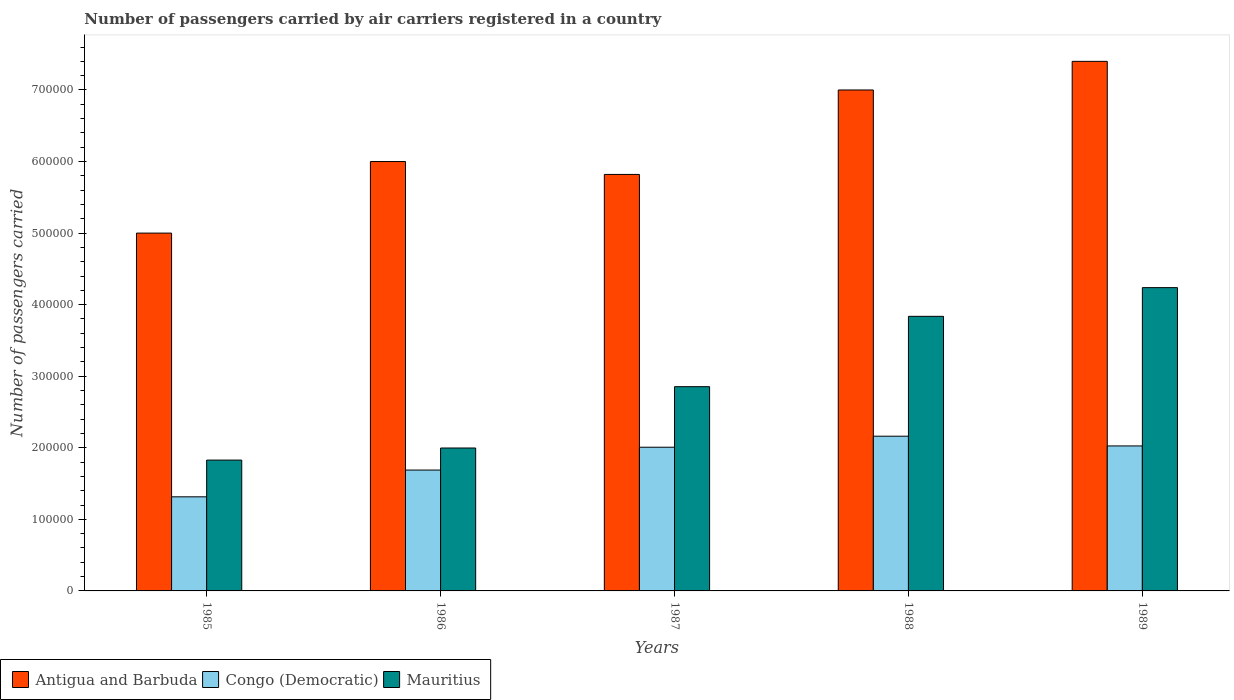How many groups of bars are there?
Keep it short and to the point. 5. How many bars are there on the 3rd tick from the left?
Your answer should be very brief. 3. What is the number of passengers carried by air carriers in Congo (Democratic) in 1987?
Offer a very short reply. 2.01e+05. Across all years, what is the maximum number of passengers carried by air carriers in Congo (Democratic)?
Offer a very short reply. 2.16e+05. Across all years, what is the minimum number of passengers carried by air carriers in Congo (Democratic)?
Ensure brevity in your answer.  1.32e+05. In which year was the number of passengers carried by air carriers in Congo (Democratic) maximum?
Offer a terse response. 1988. What is the total number of passengers carried by air carriers in Antigua and Barbuda in the graph?
Give a very brief answer. 3.12e+06. What is the difference between the number of passengers carried by air carriers in Congo (Democratic) in 1987 and that in 1988?
Your response must be concise. -1.54e+04. What is the difference between the number of passengers carried by air carriers in Antigua and Barbuda in 1986 and the number of passengers carried by air carriers in Congo (Democratic) in 1985?
Keep it short and to the point. 4.68e+05. What is the average number of passengers carried by air carriers in Antigua and Barbuda per year?
Give a very brief answer. 6.24e+05. In the year 1985, what is the difference between the number of passengers carried by air carriers in Antigua and Barbuda and number of passengers carried by air carriers in Mauritius?
Your response must be concise. 3.17e+05. What is the ratio of the number of passengers carried by air carriers in Congo (Democratic) in 1985 to that in 1986?
Offer a very short reply. 0.78. Is the number of passengers carried by air carriers in Mauritius in 1986 less than that in 1988?
Your answer should be very brief. Yes. Is the difference between the number of passengers carried by air carriers in Antigua and Barbuda in 1985 and 1988 greater than the difference between the number of passengers carried by air carriers in Mauritius in 1985 and 1988?
Provide a succinct answer. Yes. What is the difference between the highest and the lowest number of passengers carried by air carriers in Congo (Democratic)?
Give a very brief answer. 8.47e+04. In how many years, is the number of passengers carried by air carriers in Congo (Democratic) greater than the average number of passengers carried by air carriers in Congo (Democratic) taken over all years?
Offer a terse response. 3. Is the sum of the number of passengers carried by air carriers in Antigua and Barbuda in 1985 and 1989 greater than the maximum number of passengers carried by air carriers in Congo (Democratic) across all years?
Make the answer very short. Yes. What does the 1st bar from the left in 1987 represents?
Offer a very short reply. Antigua and Barbuda. What does the 1st bar from the right in 1985 represents?
Offer a terse response. Mauritius. Is it the case that in every year, the sum of the number of passengers carried by air carriers in Antigua and Barbuda and number of passengers carried by air carriers in Mauritius is greater than the number of passengers carried by air carriers in Congo (Democratic)?
Your answer should be very brief. Yes. Are all the bars in the graph horizontal?
Your response must be concise. No. How many years are there in the graph?
Offer a terse response. 5. Does the graph contain any zero values?
Your answer should be very brief. No. How are the legend labels stacked?
Ensure brevity in your answer.  Horizontal. What is the title of the graph?
Your answer should be very brief. Number of passengers carried by air carriers registered in a country. What is the label or title of the X-axis?
Offer a very short reply. Years. What is the label or title of the Y-axis?
Offer a very short reply. Number of passengers carried. What is the Number of passengers carried of Congo (Democratic) in 1985?
Offer a terse response. 1.32e+05. What is the Number of passengers carried in Mauritius in 1985?
Your answer should be very brief. 1.83e+05. What is the Number of passengers carried in Antigua and Barbuda in 1986?
Your response must be concise. 6.00e+05. What is the Number of passengers carried in Congo (Democratic) in 1986?
Your response must be concise. 1.69e+05. What is the Number of passengers carried of Mauritius in 1986?
Your answer should be very brief. 2.00e+05. What is the Number of passengers carried in Antigua and Barbuda in 1987?
Make the answer very short. 5.82e+05. What is the Number of passengers carried of Congo (Democratic) in 1987?
Provide a succinct answer. 2.01e+05. What is the Number of passengers carried of Mauritius in 1987?
Make the answer very short. 2.85e+05. What is the Number of passengers carried in Antigua and Barbuda in 1988?
Offer a very short reply. 7.00e+05. What is the Number of passengers carried in Congo (Democratic) in 1988?
Your answer should be compact. 2.16e+05. What is the Number of passengers carried in Mauritius in 1988?
Make the answer very short. 3.84e+05. What is the Number of passengers carried of Antigua and Barbuda in 1989?
Make the answer very short. 7.40e+05. What is the Number of passengers carried of Congo (Democratic) in 1989?
Provide a succinct answer. 2.03e+05. What is the Number of passengers carried in Mauritius in 1989?
Your answer should be compact. 4.24e+05. Across all years, what is the maximum Number of passengers carried of Antigua and Barbuda?
Give a very brief answer. 7.40e+05. Across all years, what is the maximum Number of passengers carried in Congo (Democratic)?
Your response must be concise. 2.16e+05. Across all years, what is the maximum Number of passengers carried of Mauritius?
Give a very brief answer. 4.24e+05. Across all years, what is the minimum Number of passengers carried of Antigua and Barbuda?
Offer a very short reply. 5.00e+05. Across all years, what is the minimum Number of passengers carried of Congo (Democratic)?
Provide a succinct answer. 1.32e+05. Across all years, what is the minimum Number of passengers carried of Mauritius?
Provide a succinct answer. 1.83e+05. What is the total Number of passengers carried of Antigua and Barbuda in the graph?
Provide a succinct answer. 3.12e+06. What is the total Number of passengers carried in Congo (Democratic) in the graph?
Provide a succinct answer. 9.20e+05. What is the total Number of passengers carried in Mauritius in the graph?
Provide a succinct answer. 1.48e+06. What is the difference between the Number of passengers carried in Antigua and Barbuda in 1985 and that in 1986?
Your answer should be compact. -1.00e+05. What is the difference between the Number of passengers carried in Congo (Democratic) in 1985 and that in 1986?
Give a very brief answer. -3.74e+04. What is the difference between the Number of passengers carried of Mauritius in 1985 and that in 1986?
Your answer should be compact. -1.69e+04. What is the difference between the Number of passengers carried of Antigua and Barbuda in 1985 and that in 1987?
Ensure brevity in your answer.  -8.20e+04. What is the difference between the Number of passengers carried of Congo (Democratic) in 1985 and that in 1987?
Your response must be concise. -6.93e+04. What is the difference between the Number of passengers carried in Mauritius in 1985 and that in 1987?
Make the answer very short. -1.03e+05. What is the difference between the Number of passengers carried in Congo (Democratic) in 1985 and that in 1988?
Offer a very short reply. -8.47e+04. What is the difference between the Number of passengers carried of Mauritius in 1985 and that in 1988?
Your response must be concise. -2.01e+05. What is the difference between the Number of passengers carried in Antigua and Barbuda in 1985 and that in 1989?
Offer a very short reply. -2.40e+05. What is the difference between the Number of passengers carried of Congo (Democratic) in 1985 and that in 1989?
Provide a short and direct response. -7.11e+04. What is the difference between the Number of passengers carried of Mauritius in 1985 and that in 1989?
Provide a short and direct response. -2.41e+05. What is the difference between the Number of passengers carried of Antigua and Barbuda in 1986 and that in 1987?
Offer a very short reply. 1.80e+04. What is the difference between the Number of passengers carried of Congo (Democratic) in 1986 and that in 1987?
Your response must be concise. -3.19e+04. What is the difference between the Number of passengers carried of Mauritius in 1986 and that in 1987?
Keep it short and to the point. -8.57e+04. What is the difference between the Number of passengers carried of Congo (Democratic) in 1986 and that in 1988?
Provide a succinct answer. -4.73e+04. What is the difference between the Number of passengers carried in Mauritius in 1986 and that in 1988?
Your response must be concise. -1.84e+05. What is the difference between the Number of passengers carried in Congo (Democratic) in 1986 and that in 1989?
Make the answer very short. -3.37e+04. What is the difference between the Number of passengers carried of Mauritius in 1986 and that in 1989?
Make the answer very short. -2.24e+05. What is the difference between the Number of passengers carried of Antigua and Barbuda in 1987 and that in 1988?
Ensure brevity in your answer.  -1.18e+05. What is the difference between the Number of passengers carried in Congo (Democratic) in 1987 and that in 1988?
Your answer should be very brief. -1.54e+04. What is the difference between the Number of passengers carried of Mauritius in 1987 and that in 1988?
Offer a terse response. -9.83e+04. What is the difference between the Number of passengers carried of Antigua and Barbuda in 1987 and that in 1989?
Offer a very short reply. -1.58e+05. What is the difference between the Number of passengers carried in Congo (Democratic) in 1987 and that in 1989?
Keep it short and to the point. -1800. What is the difference between the Number of passengers carried in Mauritius in 1987 and that in 1989?
Ensure brevity in your answer.  -1.38e+05. What is the difference between the Number of passengers carried in Congo (Democratic) in 1988 and that in 1989?
Your answer should be very brief. 1.36e+04. What is the difference between the Number of passengers carried of Mauritius in 1988 and that in 1989?
Offer a very short reply. -4.01e+04. What is the difference between the Number of passengers carried in Antigua and Barbuda in 1985 and the Number of passengers carried in Congo (Democratic) in 1986?
Your answer should be very brief. 3.31e+05. What is the difference between the Number of passengers carried in Antigua and Barbuda in 1985 and the Number of passengers carried in Mauritius in 1986?
Keep it short and to the point. 3.00e+05. What is the difference between the Number of passengers carried of Congo (Democratic) in 1985 and the Number of passengers carried of Mauritius in 1986?
Offer a very short reply. -6.82e+04. What is the difference between the Number of passengers carried in Antigua and Barbuda in 1985 and the Number of passengers carried in Congo (Democratic) in 1987?
Your answer should be very brief. 2.99e+05. What is the difference between the Number of passengers carried in Antigua and Barbuda in 1985 and the Number of passengers carried in Mauritius in 1987?
Offer a very short reply. 2.15e+05. What is the difference between the Number of passengers carried in Congo (Democratic) in 1985 and the Number of passengers carried in Mauritius in 1987?
Ensure brevity in your answer.  -1.54e+05. What is the difference between the Number of passengers carried of Antigua and Barbuda in 1985 and the Number of passengers carried of Congo (Democratic) in 1988?
Provide a succinct answer. 2.84e+05. What is the difference between the Number of passengers carried of Antigua and Barbuda in 1985 and the Number of passengers carried of Mauritius in 1988?
Keep it short and to the point. 1.16e+05. What is the difference between the Number of passengers carried in Congo (Democratic) in 1985 and the Number of passengers carried in Mauritius in 1988?
Provide a succinct answer. -2.52e+05. What is the difference between the Number of passengers carried of Antigua and Barbuda in 1985 and the Number of passengers carried of Congo (Democratic) in 1989?
Make the answer very short. 2.97e+05. What is the difference between the Number of passengers carried of Antigua and Barbuda in 1985 and the Number of passengers carried of Mauritius in 1989?
Your response must be concise. 7.62e+04. What is the difference between the Number of passengers carried of Congo (Democratic) in 1985 and the Number of passengers carried of Mauritius in 1989?
Give a very brief answer. -2.92e+05. What is the difference between the Number of passengers carried of Antigua and Barbuda in 1986 and the Number of passengers carried of Congo (Democratic) in 1987?
Ensure brevity in your answer.  3.99e+05. What is the difference between the Number of passengers carried in Antigua and Barbuda in 1986 and the Number of passengers carried in Mauritius in 1987?
Your answer should be very brief. 3.15e+05. What is the difference between the Number of passengers carried in Congo (Democratic) in 1986 and the Number of passengers carried in Mauritius in 1987?
Make the answer very short. -1.16e+05. What is the difference between the Number of passengers carried of Antigua and Barbuda in 1986 and the Number of passengers carried of Congo (Democratic) in 1988?
Your answer should be very brief. 3.84e+05. What is the difference between the Number of passengers carried of Antigua and Barbuda in 1986 and the Number of passengers carried of Mauritius in 1988?
Your answer should be very brief. 2.16e+05. What is the difference between the Number of passengers carried of Congo (Democratic) in 1986 and the Number of passengers carried of Mauritius in 1988?
Make the answer very short. -2.15e+05. What is the difference between the Number of passengers carried of Antigua and Barbuda in 1986 and the Number of passengers carried of Congo (Democratic) in 1989?
Ensure brevity in your answer.  3.97e+05. What is the difference between the Number of passengers carried of Antigua and Barbuda in 1986 and the Number of passengers carried of Mauritius in 1989?
Give a very brief answer. 1.76e+05. What is the difference between the Number of passengers carried in Congo (Democratic) in 1986 and the Number of passengers carried in Mauritius in 1989?
Give a very brief answer. -2.55e+05. What is the difference between the Number of passengers carried in Antigua and Barbuda in 1987 and the Number of passengers carried in Congo (Democratic) in 1988?
Your answer should be very brief. 3.66e+05. What is the difference between the Number of passengers carried of Antigua and Barbuda in 1987 and the Number of passengers carried of Mauritius in 1988?
Your response must be concise. 1.98e+05. What is the difference between the Number of passengers carried in Congo (Democratic) in 1987 and the Number of passengers carried in Mauritius in 1988?
Your response must be concise. -1.83e+05. What is the difference between the Number of passengers carried in Antigua and Barbuda in 1987 and the Number of passengers carried in Congo (Democratic) in 1989?
Make the answer very short. 3.79e+05. What is the difference between the Number of passengers carried in Antigua and Barbuda in 1987 and the Number of passengers carried in Mauritius in 1989?
Give a very brief answer. 1.58e+05. What is the difference between the Number of passengers carried of Congo (Democratic) in 1987 and the Number of passengers carried of Mauritius in 1989?
Your response must be concise. -2.23e+05. What is the difference between the Number of passengers carried in Antigua and Barbuda in 1988 and the Number of passengers carried in Congo (Democratic) in 1989?
Give a very brief answer. 4.97e+05. What is the difference between the Number of passengers carried in Antigua and Barbuda in 1988 and the Number of passengers carried in Mauritius in 1989?
Your answer should be compact. 2.76e+05. What is the difference between the Number of passengers carried in Congo (Democratic) in 1988 and the Number of passengers carried in Mauritius in 1989?
Provide a succinct answer. -2.08e+05. What is the average Number of passengers carried in Antigua and Barbuda per year?
Provide a short and direct response. 6.24e+05. What is the average Number of passengers carried in Congo (Democratic) per year?
Your answer should be very brief. 1.84e+05. What is the average Number of passengers carried in Mauritius per year?
Provide a succinct answer. 2.95e+05. In the year 1985, what is the difference between the Number of passengers carried in Antigua and Barbuda and Number of passengers carried in Congo (Democratic)?
Provide a short and direct response. 3.68e+05. In the year 1985, what is the difference between the Number of passengers carried in Antigua and Barbuda and Number of passengers carried in Mauritius?
Ensure brevity in your answer.  3.17e+05. In the year 1985, what is the difference between the Number of passengers carried in Congo (Democratic) and Number of passengers carried in Mauritius?
Provide a succinct answer. -5.13e+04. In the year 1986, what is the difference between the Number of passengers carried in Antigua and Barbuda and Number of passengers carried in Congo (Democratic)?
Make the answer very short. 4.31e+05. In the year 1986, what is the difference between the Number of passengers carried in Antigua and Barbuda and Number of passengers carried in Mauritius?
Your response must be concise. 4.00e+05. In the year 1986, what is the difference between the Number of passengers carried of Congo (Democratic) and Number of passengers carried of Mauritius?
Your response must be concise. -3.08e+04. In the year 1987, what is the difference between the Number of passengers carried in Antigua and Barbuda and Number of passengers carried in Congo (Democratic)?
Offer a very short reply. 3.81e+05. In the year 1987, what is the difference between the Number of passengers carried in Antigua and Barbuda and Number of passengers carried in Mauritius?
Keep it short and to the point. 2.97e+05. In the year 1987, what is the difference between the Number of passengers carried of Congo (Democratic) and Number of passengers carried of Mauritius?
Provide a short and direct response. -8.46e+04. In the year 1988, what is the difference between the Number of passengers carried of Antigua and Barbuda and Number of passengers carried of Congo (Democratic)?
Your answer should be compact. 4.84e+05. In the year 1988, what is the difference between the Number of passengers carried of Antigua and Barbuda and Number of passengers carried of Mauritius?
Make the answer very short. 3.16e+05. In the year 1988, what is the difference between the Number of passengers carried in Congo (Democratic) and Number of passengers carried in Mauritius?
Ensure brevity in your answer.  -1.68e+05. In the year 1989, what is the difference between the Number of passengers carried in Antigua and Barbuda and Number of passengers carried in Congo (Democratic)?
Your answer should be compact. 5.37e+05. In the year 1989, what is the difference between the Number of passengers carried of Antigua and Barbuda and Number of passengers carried of Mauritius?
Keep it short and to the point. 3.16e+05. In the year 1989, what is the difference between the Number of passengers carried in Congo (Democratic) and Number of passengers carried in Mauritius?
Make the answer very short. -2.21e+05. What is the ratio of the Number of passengers carried of Antigua and Barbuda in 1985 to that in 1986?
Make the answer very short. 0.83. What is the ratio of the Number of passengers carried of Congo (Democratic) in 1985 to that in 1986?
Give a very brief answer. 0.78. What is the ratio of the Number of passengers carried of Mauritius in 1985 to that in 1986?
Offer a very short reply. 0.92. What is the ratio of the Number of passengers carried in Antigua and Barbuda in 1985 to that in 1987?
Keep it short and to the point. 0.86. What is the ratio of the Number of passengers carried in Congo (Democratic) in 1985 to that in 1987?
Provide a succinct answer. 0.65. What is the ratio of the Number of passengers carried in Mauritius in 1985 to that in 1987?
Offer a very short reply. 0.64. What is the ratio of the Number of passengers carried in Antigua and Barbuda in 1985 to that in 1988?
Make the answer very short. 0.71. What is the ratio of the Number of passengers carried in Congo (Democratic) in 1985 to that in 1988?
Provide a short and direct response. 0.61. What is the ratio of the Number of passengers carried in Mauritius in 1985 to that in 1988?
Ensure brevity in your answer.  0.48. What is the ratio of the Number of passengers carried of Antigua and Barbuda in 1985 to that in 1989?
Offer a very short reply. 0.68. What is the ratio of the Number of passengers carried in Congo (Democratic) in 1985 to that in 1989?
Provide a short and direct response. 0.65. What is the ratio of the Number of passengers carried of Mauritius in 1985 to that in 1989?
Your answer should be compact. 0.43. What is the ratio of the Number of passengers carried in Antigua and Barbuda in 1986 to that in 1987?
Your response must be concise. 1.03. What is the ratio of the Number of passengers carried of Congo (Democratic) in 1986 to that in 1987?
Ensure brevity in your answer.  0.84. What is the ratio of the Number of passengers carried of Mauritius in 1986 to that in 1987?
Your answer should be very brief. 0.7. What is the ratio of the Number of passengers carried in Congo (Democratic) in 1986 to that in 1988?
Make the answer very short. 0.78. What is the ratio of the Number of passengers carried in Mauritius in 1986 to that in 1988?
Your answer should be very brief. 0.52. What is the ratio of the Number of passengers carried of Antigua and Barbuda in 1986 to that in 1989?
Keep it short and to the point. 0.81. What is the ratio of the Number of passengers carried of Congo (Democratic) in 1986 to that in 1989?
Offer a very short reply. 0.83. What is the ratio of the Number of passengers carried in Mauritius in 1986 to that in 1989?
Your response must be concise. 0.47. What is the ratio of the Number of passengers carried of Antigua and Barbuda in 1987 to that in 1988?
Ensure brevity in your answer.  0.83. What is the ratio of the Number of passengers carried of Congo (Democratic) in 1987 to that in 1988?
Offer a very short reply. 0.93. What is the ratio of the Number of passengers carried of Mauritius in 1987 to that in 1988?
Make the answer very short. 0.74. What is the ratio of the Number of passengers carried of Antigua and Barbuda in 1987 to that in 1989?
Your response must be concise. 0.79. What is the ratio of the Number of passengers carried of Mauritius in 1987 to that in 1989?
Offer a very short reply. 0.67. What is the ratio of the Number of passengers carried in Antigua and Barbuda in 1988 to that in 1989?
Offer a terse response. 0.95. What is the ratio of the Number of passengers carried in Congo (Democratic) in 1988 to that in 1989?
Give a very brief answer. 1.07. What is the ratio of the Number of passengers carried of Mauritius in 1988 to that in 1989?
Offer a terse response. 0.91. What is the difference between the highest and the second highest Number of passengers carried of Antigua and Barbuda?
Offer a terse response. 4.00e+04. What is the difference between the highest and the second highest Number of passengers carried in Congo (Democratic)?
Your answer should be compact. 1.36e+04. What is the difference between the highest and the second highest Number of passengers carried of Mauritius?
Offer a very short reply. 4.01e+04. What is the difference between the highest and the lowest Number of passengers carried in Antigua and Barbuda?
Your response must be concise. 2.40e+05. What is the difference between the highest and the lowest Number of passengers carried in Congo (Democratic)?
Provide a succinct answer. 8.47e+04. What is the difference between the highest and the lowest Number of passengers carried of Mauritius?
Make the answer very short. 2.41e+05. 